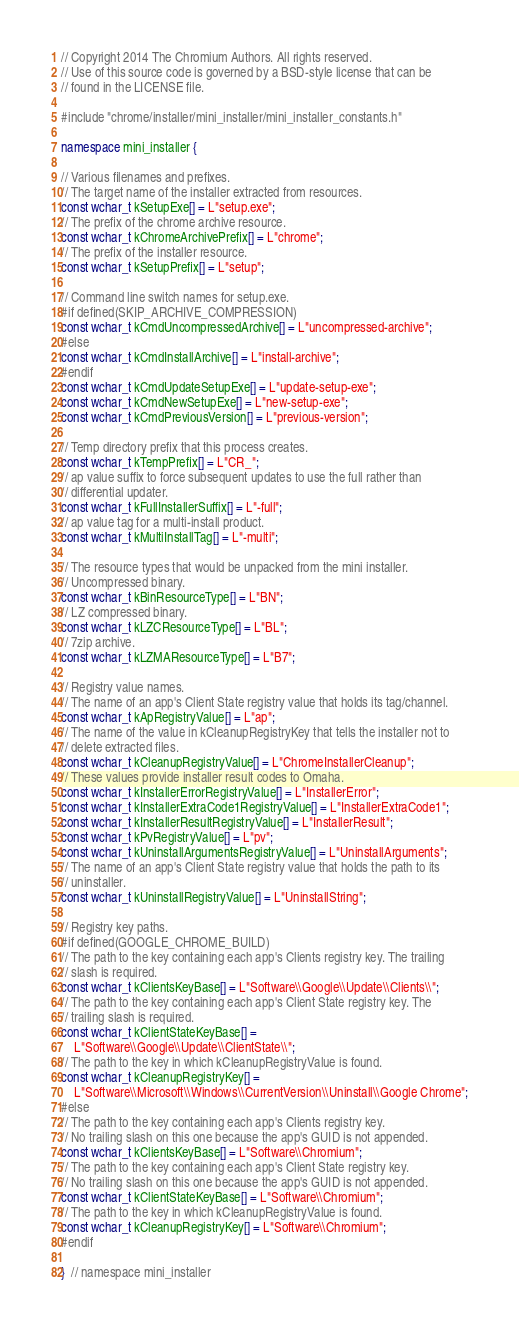Convert code to text. <code><loc_0><loc_0><loc_500><loc_500><_C++_>// Copyright 2014 The Chromium Authors. All rights reserved.
// Use of this source code is governed by a BSD-style license that can be
// found in the LICENSE file.

#include "chrome/installer/mini_installer/mini_installer_constants.h"

namespace mini_installer {

// Various filenames and prefixes.
// The target name of the installer extracted from resources.
const wchar_t kSetupExe[] = L"setup.exe";
// The prefix of the chrome archive resource.
const wchar_t kChromeArchivePrefix[] = L"chrome";
// The prefix of the installer resource.
const wchar_t kSetupPrefix[] = L"setup";

// Command line switch names for setup.exe.
#if defined(SKIP_ARCHIVE_COMPRESSION)
const wchar_t kCmdUncompressedArchive[] = L"uncompressed-archive";
#else
const wchar_t kCmdInstallArchive[] = L"install-archive";
#endif
const wchar_t kCmdUpdateSetupExe[] = L"update-setup-exe";
const wchar_t kCmdNewSetupExe[] = L"new-setup-exe";
const wchar_t kCmdPreviousVersion[] = L"previous-version";

// Temp directory prefix that this process creates.
const wchar_t kTempPrefix[] = L"CR_";
// ap value suffix to force subsequent updates to use the full rather than
// differential updater.
const wchar_t kFullInstallerSuffix[] = L"-full";
// ap value tag for a multi-install product.
const wchar_t kMultiInstallTag[] = L"-multi";

// The resource types that would be unpacked from the mini installer.
// Uncompressed binary.
const wchar_t kBinResourceType[] = L"BN";
// LZ compressed binary.
const wchar_t kLZCResourceType[] = L"BL";
// 7zip archive.
const wchar_t kLZMAResourceType[] = L"B7";

// Registry value names.
// The name of an app's Client State registry value that holds its tag/channel.
const wchar_t kApRegistryValue[] = L"ap";
// The name of the value in kCleanupRegistryKey that tells the installer not to
// delete extracted files.
const wchar_t kCleanupRegistryValue[] = L"ChromeInstallerCleanup";
// These values provide installer result codes to Omaha.
const wchar_t kInstallerErrorRegistryValue[] = L"InstallerError";
const wchar_t kInstallerExtraCode1RegistryValue[] = L"InstallerExtraCode1";
const wchar_t kInstallerResultRegistryValue[] = L"InstallerResult";
const wchar_t kPvRegistryValue[] = L"pv";
const wchar_t kUninstallArgumentsRegistryValue[] = L"UninstallArguments";
// The name of an app's Client State registry value that holds the path to its
// uninstaller.
const wchar_t kUninstallRegistryValue[] = L"UninstallString";

// Registry key paths.
#if defined(GOOGLE_CHROME_BUILD)
// The path to the key containing each app's Clients registry key. The trailing
// slash is required.
const wchar_t kClientsKeyBase[] = L"Software\\Google\\Update\\Clients\\";
// The path to the key containing each app's Client State registry key. The
// trailing slash is required.
const wchar_t kClientStateKeyBase[] =
    L"Software\\Google\\Update\\ClientState\\";
// The path to the key in which kCleanupRegistryValue is found.
const wchar_t kCleanupRegistryKey[] =
    L"Software\\Microsoft\\Windows\\CurrentVersion\\Uninstall\\Google Chrome";
#else
// The path to the key containing each app's Clients registry key.
// No trailing slash on this one because the app's GUID is not appended.
const wchar_t kClientsKeyBase[] = L"Software\\Chromium";
// The path to the key containing each app's Client State registry key.
// No trailing slash on this one because the app's GUID is not appended.
const wchar_t kClientStateKeyBase[] = L"Software\\Chromium";
// The path to the key in which kCleanupRegistryValue is found.
const wchar_t kCleanupRegistryKey[] = L"Software\\Chromium";
#endif

}  // namespace mini_installer
</code> 